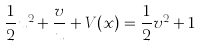Convert formula to latex. <formula><loc_0><loc_0><loc_500><loc_500>\frac { 1 } { 2 } u ^ { 2 } + \frac { v } u + V ( x ) = \frac { 1 } { 2 } v ^ { 2 } + 1</formula> 